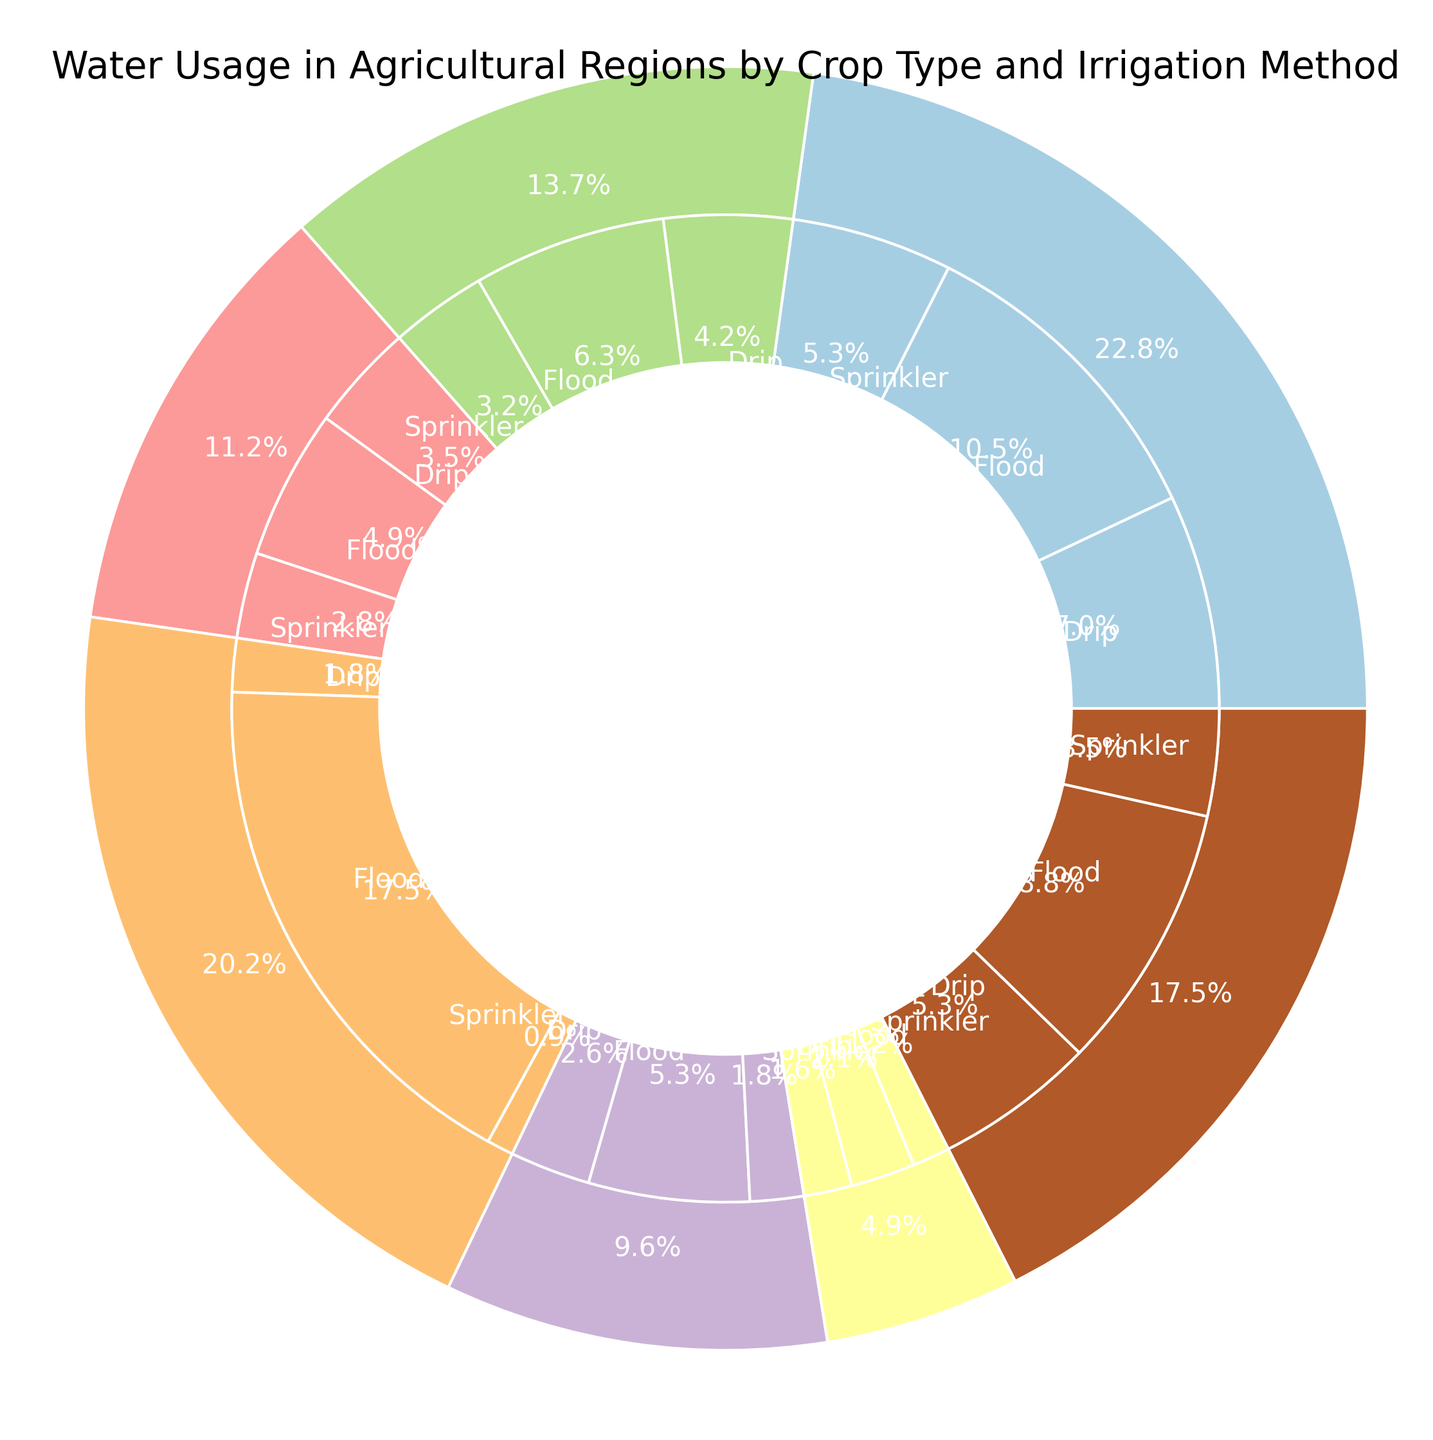What crop type uses the most water in agricultural regions? By looking at the outer pie chart, we see the segment with the largest percentage which is labeled 'Rice'. This indicates that rice uses the most water among all the crops.
Answer: Rice Which irrigation method for wheat uses the least water? Observing the inner pie chart within the 'Wheat' segment, the smallest slice belongs to 'Sprinkler', indicating that the sprinkler method uses the least water for wheat.
Answer: Sprinkler What is the combined water usage percentage of flood irrigation for rice and corn? First, identify the flood irrigation slices within the 'Rice' and 'Corn' segments on the inner pie chart. Rice flood irrigation is the largest pie slice (500 million cubic meters), and corn flood irrigation is also a sizable portion (300 million cubic meters). To get the percentages, we sum them and compare against the total. Adding 500 + 300 gives 800 million cubic meters. The total water usage of all crops combined is 3,050 million cubic meters. So the combined percentage is (800 / 3050) * 100 which simplifies to approximately 26.2%.
Answer: 26.2% Which irrigation method is most commonly used for potatoes, and what is the percentage? From the inner pie chart, the 'Potato' section indicates that flood and sprinkler methods have relatively similar sizes, but flood appears slightly larger. To confirm, look for the flood irrigation percentage within the potato segment which is 140 million cubic meters out of the total potato usage (140 + 100 + 80 = 320 million cubic meters), giving approximately (140 / 320) * 100 ≈ 43.8%.
Answer: Flood, 43.8% How does the water usage of drip irrigation for tomatoes compare to that of sprinklers for the same crop? By examining the inner pie chart sections for 'Tomato', the sizes of the drip irrigation and sprinkler segments show that drip irrigation is larger than sprinkler. Specifically, the drip uses 45 million cubic meters and the sprinkler uses 35 million cubic meters. Thus, drip irrigation uses more water than sprinklers for tomatoes.
Answer: Drip uses more than Sprinkler What is the total water usage for all the crops combined? To find the total water usage, sum up all the water usage values from the provided data across all crop types and irrigation methods. This is 250 + 150 + 100 (Wheat) + 300 + 200 + 150 (Corn) + 500 + 50 + 25 (Rice) + 150 + 75 + 50 (Soy) + 180 + 120 + 90 (Cotton) + 140 + 100 + 80 (Potato) + 60 + 45 + 35 (Tomato) = 3,050 million cubic meters.
Answer: 3,050 million cubic meters Which crop type uses the least amount of water and what is the total usage? By examining the outer pie chart, the smallest segment represents 'Tomato'. Summing the water usage values for tomato with all irrigation methods yields 60 + 45 + 35 = 140 million cubic meters.
Answer: Tomato, 140 million cubic meters 